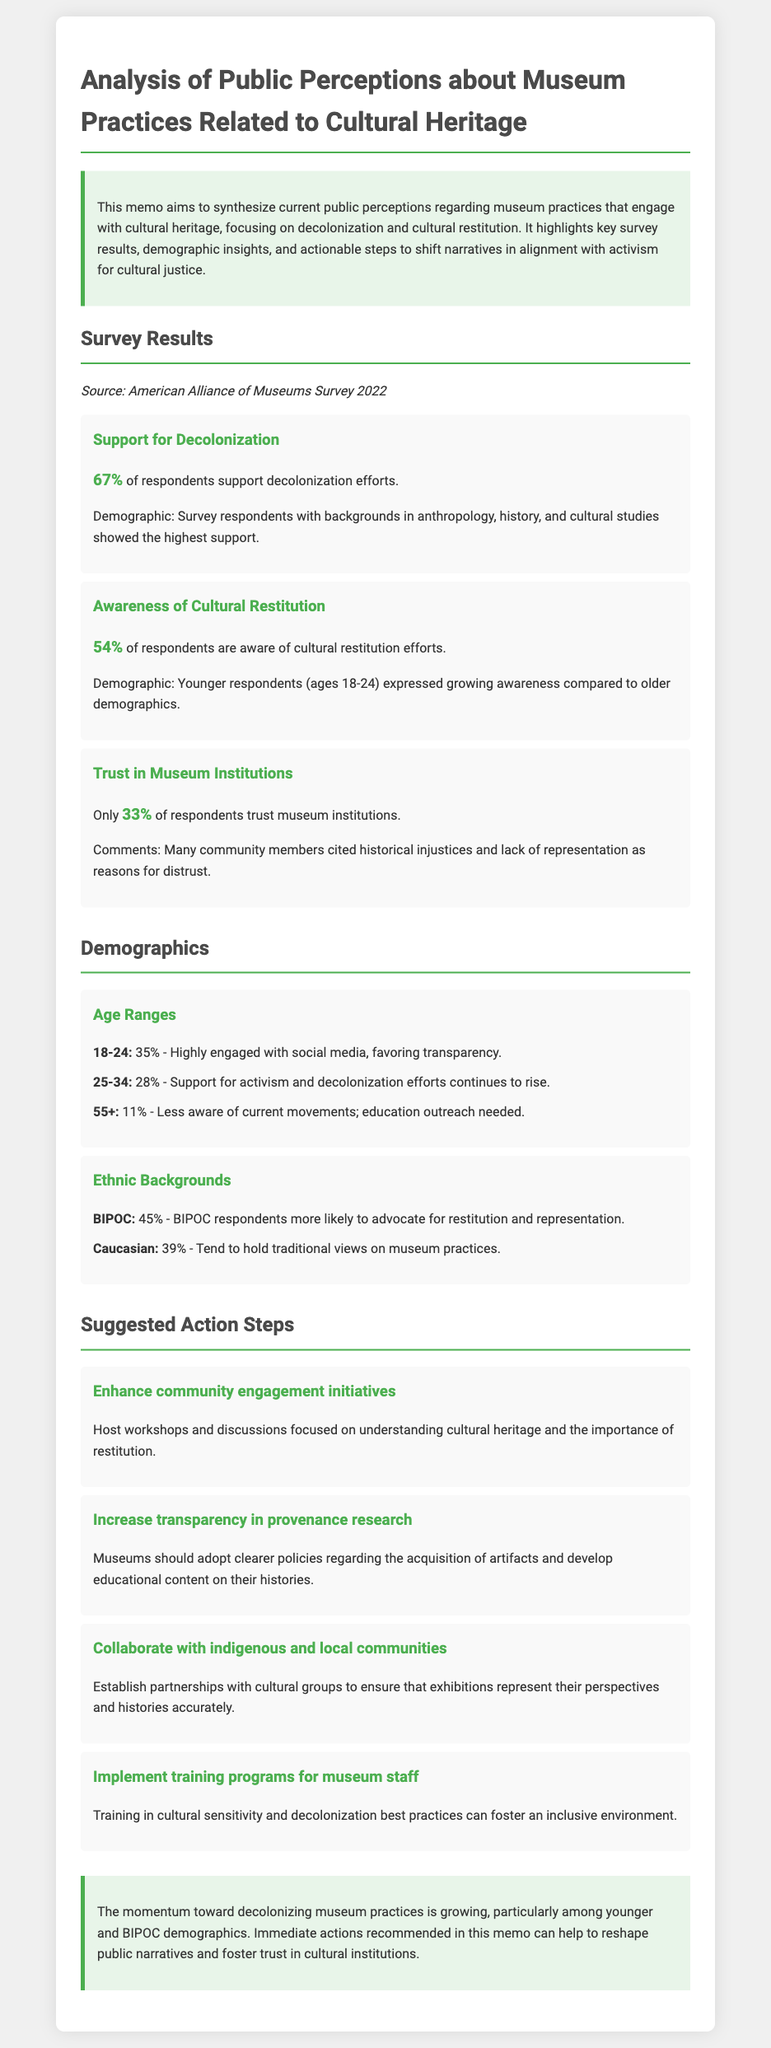What percentage of respondents support decolonization? The document states that 67% of respondents support decolonization efforts.
Answer: 67% What is the demographic group with the highest awareness of cultural restitution? Younger respondents (ages 18-24) showed growing awareness of cultural restitution efforts.
Answer: Younger respondents What percentage of respondents trust museum institutions? The document mentions that only 33% of respondents trust museum institutions.
Answer: 33% What action step involves partnering with cultural groups? The document outlines collaborating with indigenous and local communities as an action step.
Answer: Collaborate with indigenous and local communities What demographic has the highest percentage in the 18-24 age range? The survey indicates that 35% of respondents are in the 18-24 age range.
Answer: 35% What is one recommended action for fostering trust in museums? The document suggests enhancing community engagement initiatives as a way to build trust.
Answer: Enhance community engagement initiatives What is the shared trend among BIPOC respondents? BIPOC respondents are more likely to advocate for restitution and representation.
Answer: Advocate for restitution and representation Which age demographic shows rising support for activism? The 25-34 age demographic is indicated to show rising support for activism.
Answer: 25-34 What percentage of Caucasian respondents hold traditional views? The document states that 39% of Caucasian respondents tend to hold traditional views on museum practices.
Answer: 39% 